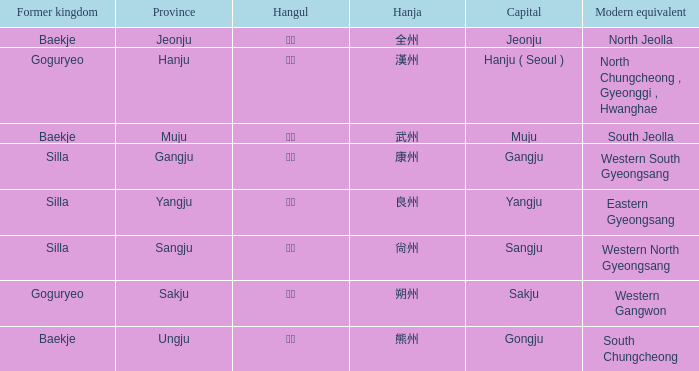What is the hanja for the province of "sangju"? 尙州. 